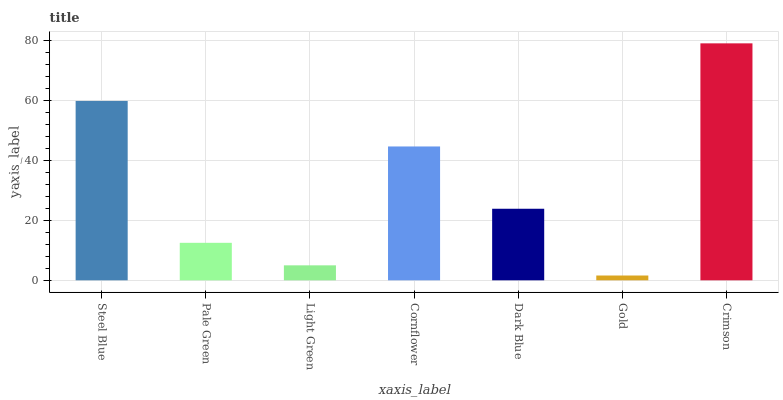Is Gold the minimum?
Answer yes or no. Yes. Is Crimson the maximum?
Answer yes or no. Yes. Is Pale Green the minimum?
Answer yes or no. No. Is Pale Green the maximum?
Answer yes or no. No. Is Steel Blue greater than Pale Green?
Answer yes or no. Yes. Is Pale Green less than Steel Blue?
Answer yes or no. Yes. Is Pale Green greater than Steel Blue?
Answer yes or no. No. Is Steel Blue less than Pale Green?
Answer yes or no. No. Is Dark Blue the high median?
Answer yes or no. Yes. Is Dark Blue the low median?
Answer yes or no. Yes. Is Steel Blue the high median?
Answer yes or no. No. Is Crimson the low median?
Answer yes or no. No. 